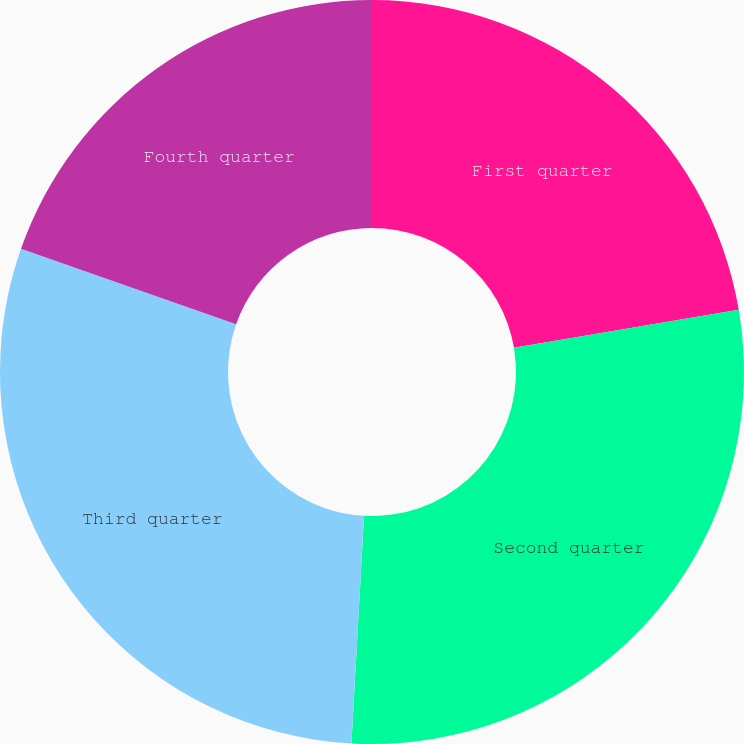<chart> <loc_0><loc_0><loc_500><loc_500><pie_chart><fcel>First quarter<fcel>Second quarter<fcel>Third quarter<fcel>Fourth quarter<nl><fcel>22.32%<fcel>28.56%<fcel>29.49%<fcel>19.63%<nl></chart> 